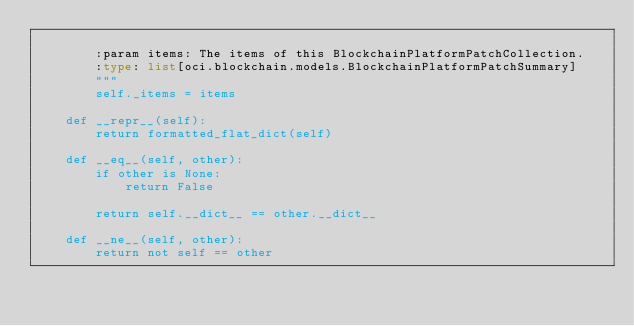<code> <loc_0><loc_0><loc_500><loc_500><_Python_>
        :param items: The items of this BlockchainPlatformPatchCollection.
        :type: list[oci.blockchain.models.BlockchainPlatformPatchSummary]
        """
        self._items = items

    def __repr__(self):
        return formatted_flat_dict(self)

    def __eq__(self, other):
        if other is None:
            return False

        return self.__dict__ == other.__dict__

    def __ne__(self, other):
        return not self == other
</code> 